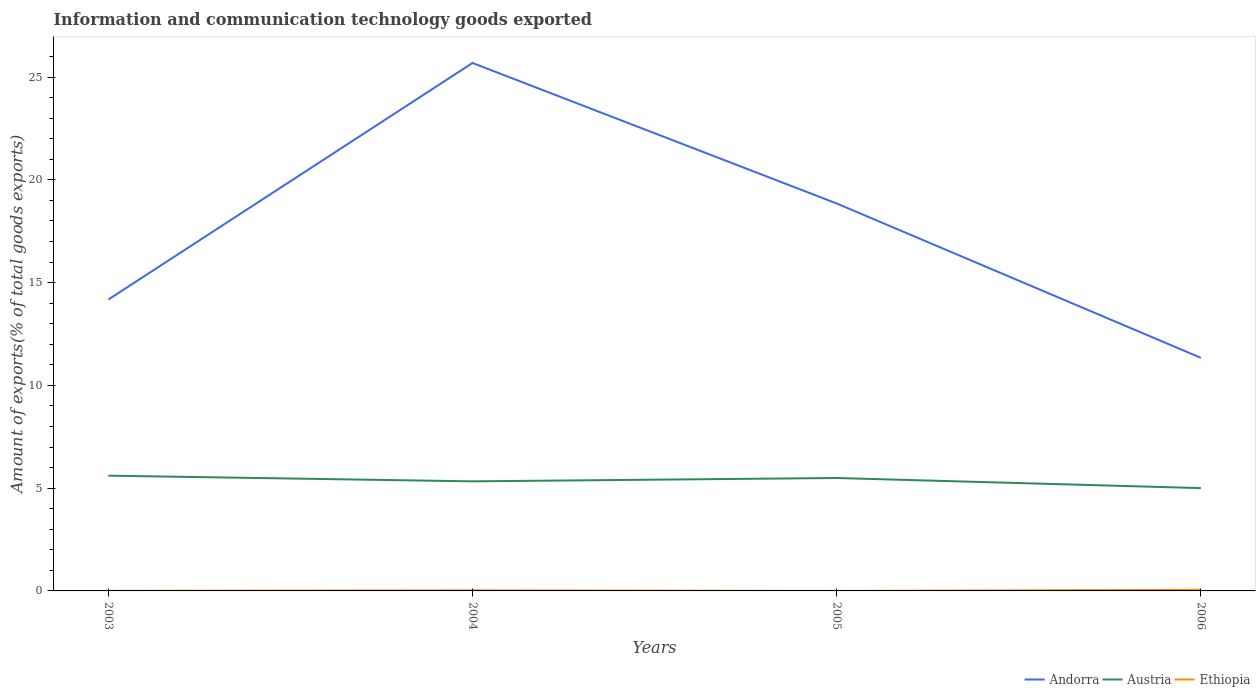How many different coloured lines are there?
Keep it short and to the point. 3. Does the line corresponding to Ethiopia intersect with the line corresponding to Andorra?
Keep it short and to the point. No. Across all years, what is the maximum amount of goods exported in Austria?
Ensure brevity in your answer.  5. In which year was the amount of goods exported in Ethiopia maximum?
Provide a succinct answer. 2005. What is the total amount of goods exported in Ethiopia in the graph?
Your answer should be compact. 0. What is the difference between the highest and the second highest amount of goods exported in Ethiopia?
Keep it short and to the point. 0.06. Is the amount of goods exported in Austria strictly greater than the amount of goods exported in Andorra over the years?
Provide a succinct answer. Yes. How many lines are there?
Offer a very short reply. 3. How many years are there in the graph?
Give a very brief answer. 4. Are the values on the major ticks of Y-axis written in scientific E-notation?
Provide a succinct answer. No. How many legend labels are there?
Provide a short and direct response. 3. What is the title of the graph?
Provide a succinct answer. Information and communication technology goods exported. Does "Northern Mariana Islands" appear as one of the legend labels in the graph?
Your response must be concise. No. What is the label or title of the X-axis?
Ensure brevity in your answer.  Years. What is the label or title of the Y-axis?
Make the answer very short. Amount of exports(% of total goods exports). What is the Amount of exports(% of total goods exports) in Andorra in 2003?
Provide a succinct answer. 14.17. What is the Amount of exports(% of total goods exports) of Austria in 2003?
Give a very brief answer. 5.61. What is the Amount of exports(% of total goods exports) in Ethiopia in 2003?
Offer a very short reply. 0. What is the Amount of exports(% of total goods exports) of Andorra in 2004?
Your answer should be compact. 25.68. What is the Amount of exports(% of total goods exports) in Austria in 2004?
Give a very brief answer. 5.33. What is the Amount of exports(% of total goods exports) in Ethiopia in 2004?
Your answer should be compact. 0.03. What is the Amount of exports(% of total goods exports) of Andorra in 2005?
Your answer should be compact. 18.85. What is the Amount of exports(% of total goods exports) of Austria in 2005?
Offer a very short reply. 5.49. What is the Amount of exports(% of total goods exports) in Ethiopia in 2005?
Offer a very short reply. 5.79786e-5. What is the Amount of exports(% of total goods exports) in Andorra in 2006?
Offer a very short reply. 11.34. What is the Amount of exports(% of total goods exports) in Austria in 2006?
Make the answer very short. 5. What is the Amount of exports(% of total goods exports) in Ethiopia in 2006?
Provide a succinct answer. 0.06. Across all years, what is the maximum Amount of exports(% of total goods exports) of Andorra?
Keep it short and to the point. 25.68. Across all years, what is the maximum Amount of exports(% of total goods exports) of Austria?
Provide a short and direct response. 5.61. Across all years, what is the maximum Amount of exports(% of total goods exports) of Ethiopia?
Ensure brevity in your answer.  0.06. Across all years, what is the minimum Amount of exports(% of total goods exports) in Andorra?
Provide a short and direct response. 11.34. Across all years, what is the minimum Amount of exports(% of total goods exports) of Austria?
Provide a succinct answer. 5. Across all years, what is the minimum Amount of exports(% of total goods exports) of Ethiopia?
Provide a short and direct response. 5.79786e-5. What is the total Amount of exports(% of total goods exports) of Andorra in the graph?
Provide a short and direct response. 70.04. What is the total Amount of exports(% of total goods exports) in Austria in the graph?
Give a very brief answer. 21.43. What is the total Amount of exports(% of total goods exports) of Ethiopia in the graph?
Provide a succinct answer. 0.09. What is the difference between the Amount of exports(% of total goods exports) of Andorra in 2003 and that in 2004?
Keep it short and to the point. -11.51. What is the difference between the Amount of exports(% of total goods exports) in Austria in 2003 and that in 2004?
Your answer should be very brief. 0.28. What is the difference between the Amount of exports(% of total goods exports) of Ethiopia in 2003 and that in 2004?
Provide a succinct answer. -0.02. What is the difference between the Amount of exports(% of total goods exports) of Andorra in 2003 and that in 2005?
Provide a succinct answer. -4.67. What is the difference between the Amount of exports(% of total goods exports) of Austria in 2003 and that in 2005?
Offer a terse response. 0.11. What is the difference between the Amount of exports(% of total goods exports) of Ethiopia in 2003 and that in 2005?
Make the answer very short. 0. What is the difference between the Amount of exports(% of total goods exports) of Andorra in 2003 and that in 2006?
Provide a succinct answer. 2.84. What is the difference between the Amount of exports(% of total goods exports) of Austria in 2003 and that in 2006?
Keep it short and to the point. 0.6. What is the difference between the Amount of exports(% of total goods exports) in Ethiopia in 2003 and that in 2006?
Provide a short and direct response. -0.05. What is the difference between the Amount of exports(% of total goods exports) in Andorra in 2004 and that in 2005?
Your answer should be compact. 6.83. What is the difference between the Amount of exports(% of total goods exports) in Austria in 2004 and that in 2005?
Provide a short and direct response. -0.16. What is the difference between the Amount of exports(% of total goods exports) of Ethiopia in 2004 and that in 2005?
Your answer should be very brief. 0.03. What is the difference between the Amount of exports(% of total goods exports) of Andorra in 2004 and that in 2006?
Provide a short and direct response. 14.34. What is the difference between the Amount of exports(% of total goods exports) in Austria in 2004 and that in 2006?
Offer a very short reply. 0.33. What is the difference between the Amount of exports(% of total goods exports) of Ethiopia in 2004 and that in 2006?
Ensure brevity in your answer.  -0.03. What is the difference between the Amount of exports(% of total goods exports) in Andorra in 2005 and that in 2006?
Your response must be concise. 7.51. What is the difference between the Amount of exports(% of total goods exports) of Austria in 2005 and that in 2006?
Offer a terse response. 0.49. What is the difference between the Amount of exports(% of total goods exports) of Ethiopia in 2005 and that in 2006?
Offer a very short reply. -0.06. What is the difference between the Amount of exports(% of total goods exports) in Andorra in 2003 and the Amount of exports(% of total goods exports) in Austria in 2004?
Provide a short and direct response. 8.84. What is the difference between the Amount of exports(% of total goods exports) of Andorra in 2003 and the Amount of exports(% of total goods exports) of Ethiopia in 2004?
Provide a short and direct response. 14.15. What is the difference between the Amount of exports(% of total goods exports) of Austria in 2003 and the Amount of exports(% of total goods exports) of Ethiopia in 2004?
Offer a very short reply. 5.58. What is the difference between the Amount of exports(% of total goods exports) in Andorra in 2003 and the Amount of exports(% of total goods exports) in Austria in 2005?
Your answer should be very brief. 8.68. What is the difference between the Amount of exports(% of total goods exports) of Andorra in 2003 and the Amount of exports(% of total goods exports) of Ethiopia in 2005?
Keep it short and to the point. 14.17. What is the difference between the Amount of exports(% of total goods exports) in Austria in 2003 and the Amount of exports(% of total goods exports) in Ethiopia in 2005?
Give a very brief answer. 5.61. What is the difference between the Amount of exports(% of total goods exports) in Andorra in 2003 and the Amount of exports(% of total goods exports) in Austria in 2006?
Offer a terse response. 9.17. What is the difference between the Amount of exports(% of total goods exports) in Andorra in 2003 and the Amount of exports(% of total goods exports) in Ethiopia in 2006?
Make the answer very short. 14.12. What is the difference between the Amount of exports(% of total goods exports) in Austria in 2003 and the Amount of exports(% of total goods exports) in Ethiopia in 2006?
Offer a very short reply. 5.55. What is the difference between the Amount of exports(% of total goods exports) in Andorra in 2004 and the Amount of exports(% of total goods exports) in Austria in 2005?
Make the answer very short. 20.19. What is the difference between the Amount of exports(% of total goods exports) in Andorra in 2004 and the Amount of exports(% of total goods exports) in Ethiopia in 2005?
Provide a succinct answer. 25.68. What is the difference between the Amount of exports(% of total goods exports) of Austria in 2004 and the Amount of exports(% of total goods exports) of Ethiopia in 2005?
Ensure brevity in your answer.  5.33. What is the difference between the Amount of exports(% of total goods exports) in Andorra in 2004 and the Amount of exports(% of total goods exports) in Austria in 2006?
Ensure brevity in your answer.  20.68. What is the difference between the Amount of exports(% of total goods exports) in Andorra in 2004 and the Amount of exports(% of total goods exports) in Ethiopia in 2006?
Provide a short and direct response. 25.63. What is the difference between the Amount of exports(% of total goods exports) of Austria in 2004 and the Amount of exports(% of total goods exports) of Ethiopia in 2006?
Provide a succinct answer. 5.27. What is the difference between the Amount of exports(% of total goods exports) of Andorra in 2005 and the Amount of exports(% of total goods exports) of Austria in 2006?
Offer a terse response. 13.85. What is the difference between the Amount of exports(% of total goods exports) of Andorra in 2005 and the Amount of exports(% of total goods exports) of Ethiopia in 2006?
Your answer should be very brief. 18.79. What is the difference between the Amount of exports(% of total goods exports) in Austria in 2005 and the Amount of exports(% of total goods exports) in Ethiopia in 2006?
Offer a very short reply. 5.44. What is the average Amount of exports(% of total goods exports) of Andorra per year?
Your answer should be compact. 17.51. What is the average Amount of exports(% of total goods exports) in Austria per year?
Your answer should be compact. 5.36. What is the average Amount of exports(% of total goods exports) in Ethiopia per year?
Make the answer very short. 0.02. In the year 2003, what is the difference between the Amount of exports(% of total goods exports) in Andorra and Amount of exports(% of total goods exports) in Austria?
Your answer should be compact. 8.57. In the year 2003, what is the difference between the Amount of exports(% of total goods exports) in Andorra and Amount of exports(% of total goods exports) in Ethiopia?
Ensure brevity in your answer.  14.17. In the year 2003, what is the difference between the Amount of exports(% of total goods exports) in Austria and Amount of exports(% of total goods exports) in Ethiopia?
Ensure brevity in your answer.  5.6. In the year 2004, what is the difference between the Amount of exports(% of total goods exports) of Andorra and Amount of exports(% of total goods exports) of Austria?
Offer a terse response. 20.35. In the year 2004, what is the difference between the Amount of exports(% of total goods exports) in Andorra and Amount of exports(% of total goods exports) in Ethiopia?
Your response must be concise. 25.65. In the year 2004, what is the difference between the Amount of exports(% of total goods exports) of Austria and Amount of exports(% of total goods exports) of Ethiopia?
Make the answer very short. 5.3. In the year 2005, what is the difference between the Amount of exports(% of total goods exports) of Andorra and Amount of exports(% of total goods exports) of Austria?
Make the answer very short. 13.35. In the year 2005, what is the difference between the Amount of exports(% of total goods exports) of Andorra and Amount of exports(% of total goods exports) of Ethiopia?
Your answer should be compact. 18.85. In the year 2005, what is the difference between the Amount of exports(% of total goods exports) in Austria and Amount of exports(% of total goods exports) in Ethiopia?
Ensure brevity in your answer.  5.49. In the year 2006, what is the difference between the Amount of exports(% of total goods exports) of Andorra and Amount of exports(% of total goods exports) of Austria?
Your response must be concise. 6.34. In the year 2006, what is the difference between the Amount of exports(% of total goods exports) of Andorra and Amount of exports(% of total goods exports) of Ethiopia?
Your answer should be very brief. 11.28. In the year 2006, what is the difference between the Amount of exports(% of total goods exports) in Austria and Amount of exports(% of total goods exports) in Ethiopia?
Your answer should be very brief. 4.95. What is the ratio of the Amount of exports(% of total goods exports) of Andorra in 2003 to that in 2004?
Your answer should be compact. 0.55. What is the ratio of the Amount of exports(% of total goods exports) in Austria in 2003 to that in 2004?
Offer a terse response. 1.05. What is the ratio of the Amount of exports(% of total goods exports) of Ethiopia in 2003 to that in 2004?
Provide a short and direct response. 0.17. What is the ratio of the Amount of exports(% of total goods exports) in Andorra in 2003 to that in 2005?
Your response must be concise. 0.75. What is the ratio of the Amount of exports(% of total goods exports) of Austria in 2003 to that in 2005?
Keep it short and to the point. 1.02. What is the ratio of the Amount of exports(% of total goods exports) of Ethiopia in 2003 to that in 2005?
Give a very brief answer. 82.87. What is the ratio of the Amount of exports(% of total goods exports) in Austria in 2003 to that in 2006?
Provide a succinct answer. 1.12. What is the ratio of the Amount of exports(% of total goods exports) in Ethiopia in 2003 to that in 2006?
Keep it short and to the point. 0.09. What is the ratio of the Amount of exports(% of total goods exports) in Andorra in 2004 to that in 2005?
Provide a short and direct response. 1.36. What is the ratio of the Amount of exports(% of total goods exports) in Austria in 2004 to that in 2005?
Provide a succinct answer. 0.97. What is the ratio of the Amount of exports(% of total goods exports) in Ethiopia in 2004 to that in 2005?
Offer a very short reply. 487.03. What is the ratio of the Amount of exports(% of total goods exports) in Andorra in 2004 to that in 2006?
Give a very brief answer. 2.26. What is the ratio of the Amount of exports(% of total goods exports) in Austria in 2004 to that in 2006?
Your response must be concise. 1.07. What is the ratio of the Amount of exports(% of total goods exports) in Ethiopia in 2004 to that in 2006?
Your answer should be very brief. 0.5. What is the ratio of the Amount of exports(% of total goods exports) of Andorra in 2005 to that in 2006?
Offer a terse response. 1.66. What is the ratio of the Amount of exports(% of total goods exports) in Austria in 2005 to that in 2006?
Ensure brevity in your answer.  1.1. What is the difference between the highest and the second highest Amount of exports(% of total goods exports) of Andorra?
Your response must be concise. 6.83. What is the difference between the highest and the second highest Amount of exports(% of total goods exports) in Austria?
Keep it short and to the point. 0.11. What is the difference between the highest and the second highest Amount of exports(% of total goods exports) of Ethiopia?
Your response must be concise. 0.03. What is the difference between the highest and the lowest Amount of exports(% of total goods exports) of Andorra?
Keep it short and to the point. 14.34. What is the difference between the highest and the lowest Amount of exports(% of total goods exports) of Austria?
Make the answer very short. 0.6. What is the difference between the highest and the lowest Amount of exports(% of total goods exports) of Ethiopia?
Offer a very short reply. 0.06. 